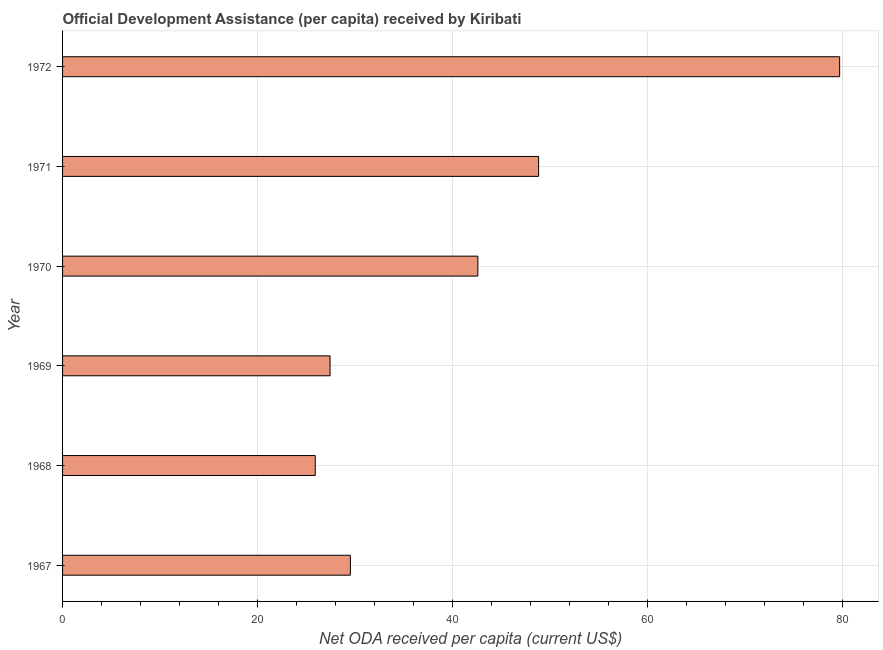Does the graph contain grids?
Offer a very short reply. Yes. What is the title of the graph?
Your answer should be compact. Official Development Assistance (per capita) received by Kiribati. What is the label or title of the X-axis?
Make the answer very short. Net ODA received per capita (current US$). What is the net oda received per capita in 1970?
Offer a terse response. 42.59. Across all years, what is the maximum net oda received per capita?
Offer a terse response. 79.7. Across all years, what is the minimum net oda received per capita?
Your answer should be very brief. 25.92. In which year was the net oda received per capita maximum?
Make the answer very short. 1972. In which year was the net oda received per capita minimum?
Make the answer very short. 1968. What is the sum of the net oda received per capita?
Keep it short and to the point. 253.99. What is the difference between the net oda received per capita in 1967 and 1971?
Provide a succinct answer. -19.31. What is the average net oda received per capita per year?
Keep it short and to the point. 42.33. What is the median net oda received per capita?
Your answer should be compact. 36.06. What is the ratio of the net oda received per capita in 1969 to that in 1971?
Provide a succinct answer. 0.56. What is the difference between the highest and the second highest net oda received per capita?
Keep it short and to the point. 30.87. Is the sum of the net oda received per capita in 1967 and 1971 greater than the maximum net oda received per capita across all years?
Offer a terse response. No. What is the difference between the highest and the lowest net oda received per capita?
Keep it short and to the point. 53.78. In how many years, is the net oda received per capita greater than the average net oda received per capita taken over all years?
Provide a succinct answer. 3. Are all the bars in the graph horizontal?
Make the answer very short. Yes. How many years are there in the graph?
Ensure brevity in your answer.  6. What is the difference between two consecutive major ticks on the X-axis?
Offer a terse response. 20. What is the Net ODA received per capita (current US$) of 1967?
Offer a terse response. 29.52. What is the Net ODA received per capita (current US$) of 1968?
Make the answer very short. 25.92. What is the Net ODA received per capita (current US$) in 1969?
Ensure brevity in your answer.  27.43. What is the Net ODA received per capita (current US$) of 1970?
Your response must be concise. 42.59. What is the Net ODA received per capita (current US$) of 1971?
Your answer should be compact. 48.83. What is the Net ODA received per capita (current US$) in 1972?
Offer a terse response. 79.7. What is the difference between the Net ODA received per capita (current US$) in 1967 and 1968?
Ensure brevity in your answer.  3.6. What is the difference between the Net ODA received per capita (current US$) in 1967 and 1969?
Offer a terse response. 2.09. What is the difference between the Net ODA received per capita (current US$) in 1967 and 1970?
Give a very brief answer. -13.07. What is the difference between the Net ODA received per capita (current US$) in 1967 and 1971?
Your answer should be very brief. -19.31. What is the difference between the Net ODA received per capita (current US$) in 1967 and 1972?
Keep it short and to the point. -50.18. What is the difference between the Net ODA received per capita (current US$) in 1968 and 1969?
Ensure brevity in your answer.  -1.52. What is the difference between the Net ODA received per capita (current US$) in 1968 and 1970?
Give a very brief answer. -16.68. What is the difference between the Net ODA received per capita (current US$) in 1968 and 1971?
Provide a succinct answer. -22.91. What is the difference between the Net ODA received per capita (current US$) in 1968 and 1972?
Offer a terse response. -53.78. What is the difference between the Net ODA received per capita (current US$) in 1969 and 1970?
Provide a short and direct response. -15.16. What is the difference between the Net ODA received per capita (current US$) in 1969 and 1971?
Offer a terse response. -21.39. What is the difference between the Net ODA received per capita (current US$) in 1969 and 1972?
Offer a very short reply. -52.27. What is the difference between the Net ODA received per capita (current US$) in 1970 and 1971?
Your response must be concise. -6.23. What is the difference between the Net ODA received per capita (current US$) in 1970 and 1972?
Give a very brief answer. -37.11. What is the difference between the Net ODA received per capita (current US$) in 1971 and 1972?
Ensure brevity in your answer.  -30.87. What is the ratio of the Net ODA received per capita (current US$) in 1967 to that in 1968?
Provide a succinct answer. 1.14. What is the ratio of the Net ODA received per capita (current US$) in 1967 to that in 1969?
Ensure brevity in your answer.  1.08. What is the ratio of the Net ODA received per capita (current US$) in 1967 to that in 1970?
Keep it short and to the point. 0.69. What is the ratio of the Net ODA received per capita (current US$) in 1967 to that in 1971?
Your answer should be very brief. 0.6. What is the ratio of the Net ODA received per capita (current US$) in 1967 to that in 1972?
Ensure brevity in your answer.  0.37. What is the ratio of the Net ODA received per capita (current US$) in 1968 to that in 1969?
Your response must be concise. 0.94. What is the ratio of the Net ODA received per capita (current US$) in 1968 to that in 1970?
Offer a very short reply. 0.61. What is the ratio of the Net ODA received per capita (current US$) in 1968 to that in 1971?
Keep it short and to the point. 0.53. What is the ratio of the Net ODA received per capita (current US$) in 1968 to that in 1972?
Your response must be concise. 0.33. What is the ratio of the Net ODA received per capita (current US$) in 1969 to that in 1970?
Your answer should be very brief. 0.64. What is the ratio of the Net ODA received per capita (current US$) in 1969 to that in 1971?
Provide a succinct answer. 0.56. What is the ratio of the Net ODA received per capita (current US$) in 1969 to that in 1972?
Ensure brevity in your answer.  0.34. What is the ratio of the Net ODA received per capita (current US$) in 1970 to that in 1971?
Make the answer very short. 0.87. What is the ratio of the Net ODA received per capita (current US$) in 1970 to that in 1972?
Your answer should be very brief. 0.53. What is the ratio of the Net ODA received per capita (current US$) in 1971 to that in 1972?
Offer a very short reply. 0.61. 